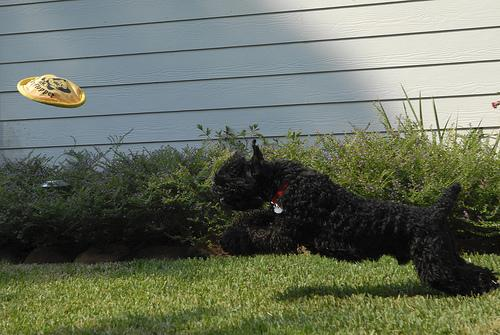Deduce the main focus of the image and what action that subject is undertaking. The main focus of the image is the black dog, who is running after or jumping to catch the frisbee in mid-air. What is the primary object in the air? A frisbee is the primary object in the air. List the colors and body parts of the dog that are visible in this image. The dog is black with a red collar, a head, tail, ear, and four feet. Analyze the dog's interaction with the frisbee. The dog is chasing or jumping to catch the frisbee in mid-air. What is the overall sentiment in the image for a viewer? The overall sentiment in the image is lively and joyful as the dog is playing and chasing the frisbee. Is the dog wearing a blue collar? No, it's not mentioned in the image. Is a frisbee shown flying in the air, and if yes, what are its colors? Yes, it is a yellow and black frisbee. Which object is positioned at X:43 Y:170? a black solar light in a flower bed List all the feet of the dog mentioned in the image. foot of the dog (217, 226), foot of the dog (462, 262), foot of the dog (234, 206) What type of tag does the dog's collar have? a metal tag Identify the presence and color of any flowers in the image. red flowers What type of collar does the dog have? red collar Which object is found at the left-top corner with Width:70 and Height:70? a frisbee Identify the type of shadows found in the image. shadow on a wall, shadow under a dog, shadow on grass Mention the position and appearance of the red flower in the image. The red flower is located at (491, 95). Does the black dog have anything special located at X:243 Y:138? Yes, the ear of the dog. What is the color and appearance of the house? white house with siding What is the large object measuring Width:291 and Height:291? a black dog Does the black dog have a collar, tag, and is it running? Yes, the black dog has a red collar with a metal tag and is running. How many bushes are aligned along the house? several bushes or flowers What type of ground is shown in the image and is it mentioned by any other name? Grass, also called green grass. Describe the interaction between the black dog and the frisbee. The black dog is running after and jumping to catch the frisbee. What type of light is present in the flower bed? a black solar light Where are the two front legs of the dog located, and what are their sizes? The two front legs are located at (205, 214) with Width:93 and Height:93. Does the dog's tail have a particular mention in the image? Yes, the tail of the dog is mentioned. 